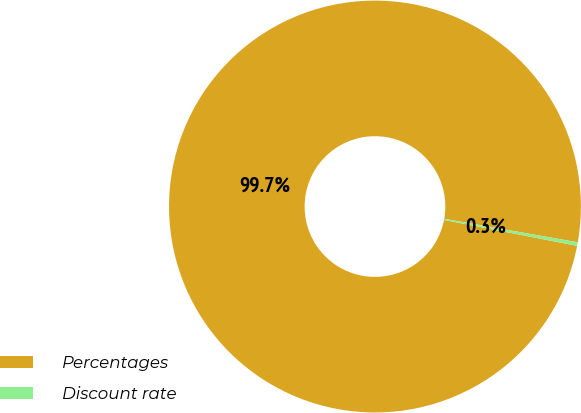<chart> <loc_0><loc_0><loc_500><loc_500><pie_chart><fcel>Percentages<fcel>Discount rate<nl><fcel>99.72%<fcel>0.28%<nl></chart> 